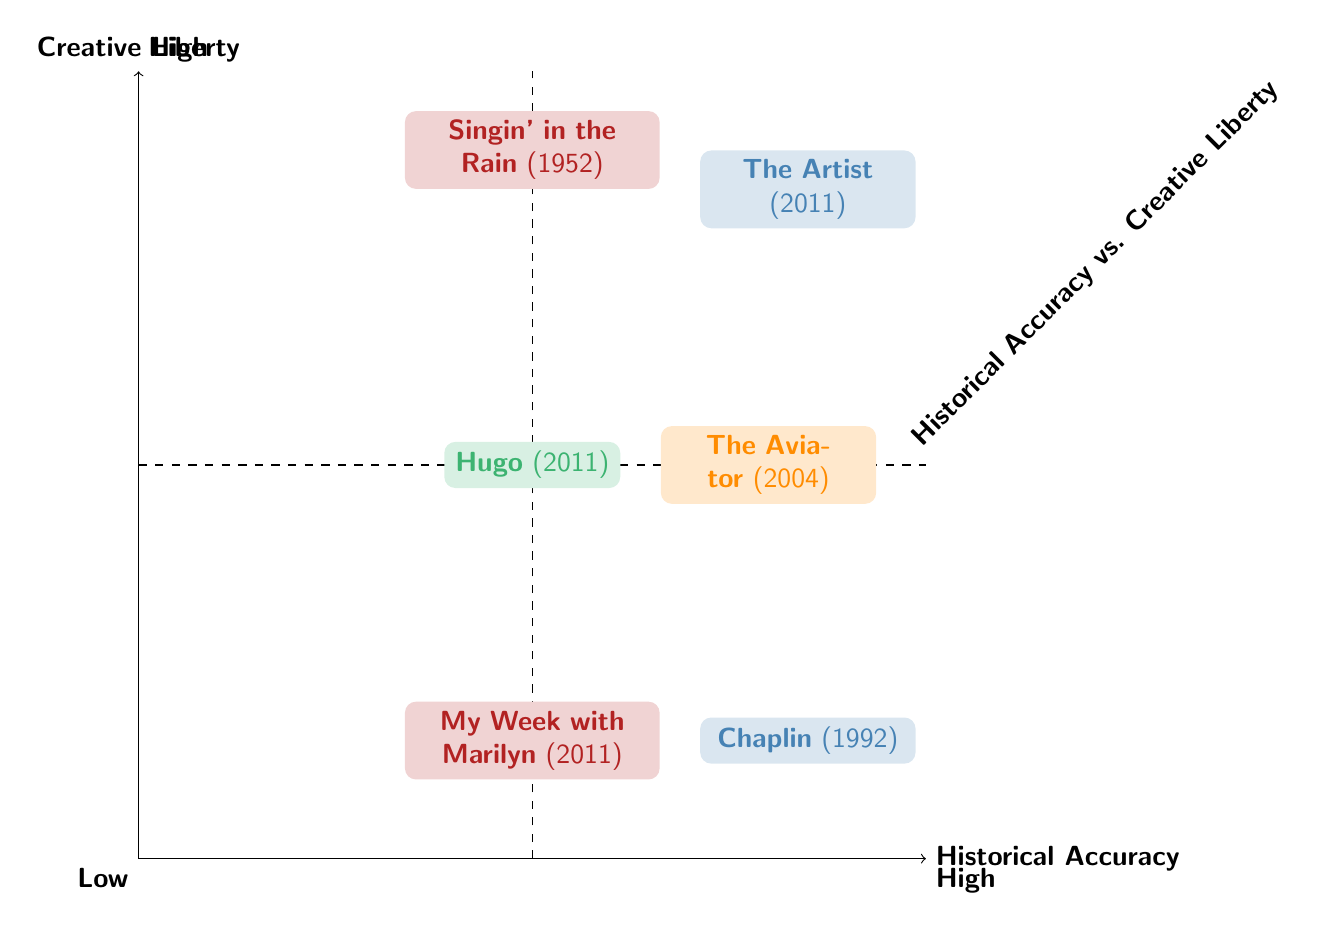What is the positioning of "The Artist" in terms of historical accuracy and creative liberty? "The Artist" is positioned in the high category for both historical accuracy and creative liberty, which is visually represented in the upper right quadrant of the diagram.
Answer: High How many films have high historical accuracy and low creative liberty? In the diagram, only one film, "Chaplin" (1992), is positioned in the high historical accuracy and low creative liberty quadrant (bottom left), hence there is only one film in this category.
Answer: 1 Which film has the lowest creative liberty? The film "Chaplin" (1992) is located in the low creative liberty quadrant (lower left). This confirms that it has the lowest creative liberty compared to the others represented in the chart.
Answer: Chaplin (1992) What is the historical accuracy level of "Hugo"? "Hugo" is positioned in the medium historical accuracy section of the diagram, specifically in the middle left quadrant, indicating it does not achieve high historical accuracy.
Answer: Medium Is there any film that balances high historical accuracy and medium creative liberty? Yes, "The Aviator" (2004) is positioned in the upper middle area of the diagram, which shows it maintains a high historical accuracy while having a medium level of creative liberty.
Answer: The Aviator (2004) Which two films share the same creative liberty level of high? "The Artist" (2011) and "Singin' in the Rain" (1952) are both positioned in the high creative liberty quadrant, indicating they share the same level of creative liberty.
Answer: The Artist and Singin' in the Rain How many films are in the medium historical accuracy category? There are three films—“Hugo” (2011), “Singin' in the Rain” (1952), and “My Week with Marilyn” (2011)—that fall under the medium historical accuracy category, as they are scattered in the left half of the diagram.
Answer: 3 Which film lies exactly in the middle of the chart? "Hugo" (2011) is located at the intersection of the medium historical accuracy and medium creative liberty, making it the only film that lies exactly in the middle of the chart.
Answer: Hugo (2011) 